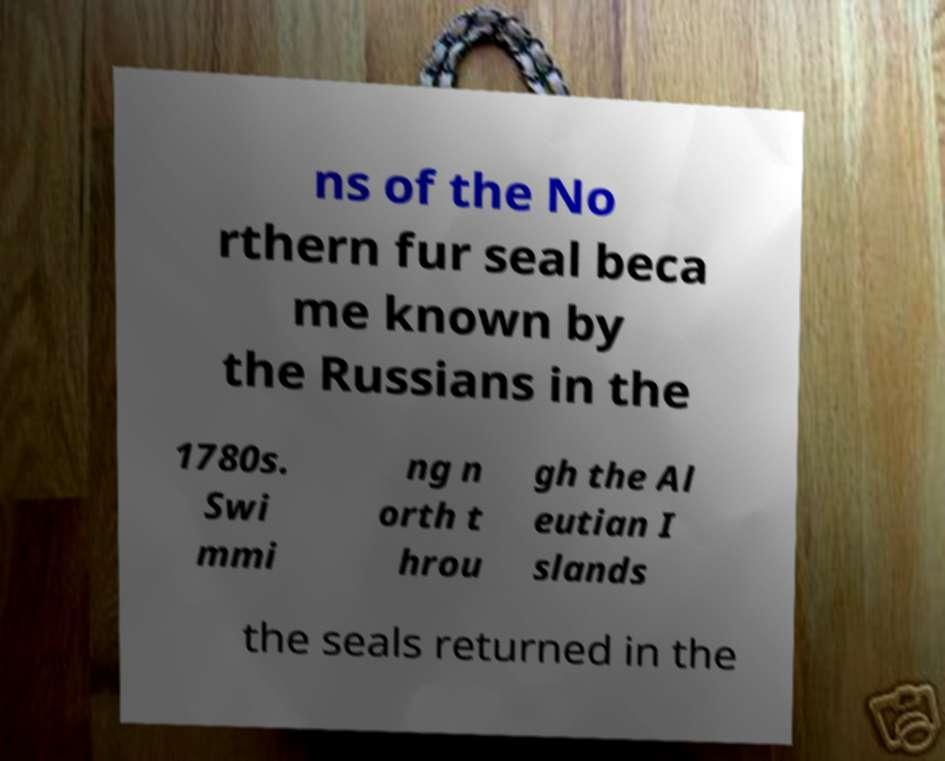Please read and relay the text visible in this image. What does it say? ns of the No rthern fur seal beca me known by the Russians in the 1780s. Swi mmi ng n orth t hrou gh the Al eutian I slands the seals returned in the 